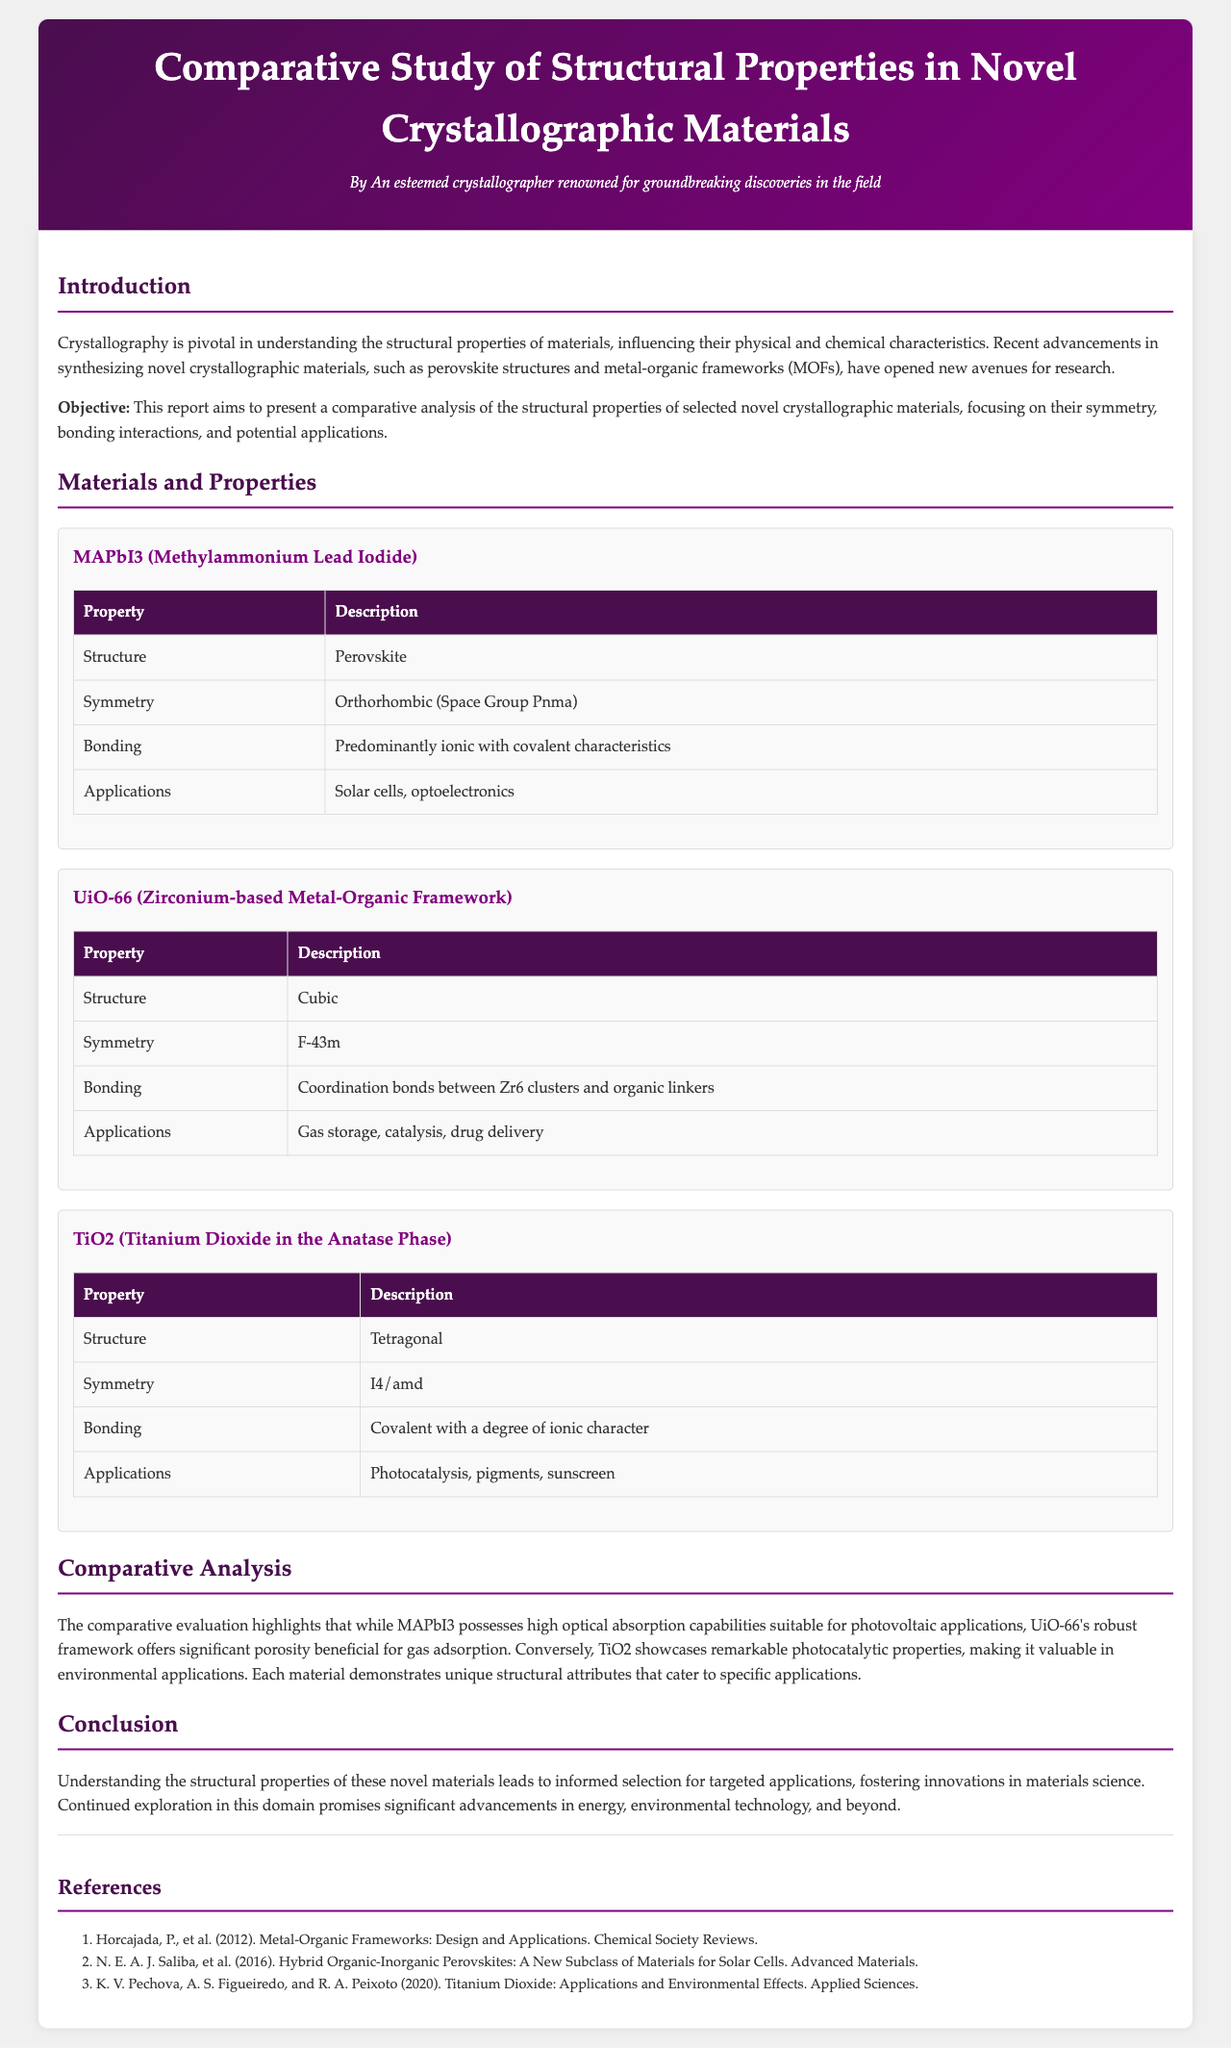what is the main objective of the report? The report aims to present a comparative analysis of the structural properties of selected novel crystallographic materials, focusing on their symmetry, bonding interactions, and potential applications.
Answer: comparative analysis of the structural properties which material has an orthorhombic symmetry? MAPbI3 is specified as having orthorhombic symmetry with Space Group Pnma.
Answer: MAPbI3 what type of bonding is predominantly found in UiO-66? The report indicates that UiO-66 has coordination bonds between Zr6 clusters and organic linkers.
Answer: Coordination bonds what is the application of MAPbI3 mentioned in the report? MAPbI3 is noted for applications in solar cells and optoelectronics.
Answer: Solar cells, optoelectronics which material is described as having remarkable photocatalytic properties? The report states that TiO2 showcases remarkable photocatalytic properties.
Answer: TiO2 what is the structure type of UiO-66? The structure type of UiO-66 is cubic.
Answer: Cubic how many references are listed in the report? The document contains three references listed under the References section.
Answer: Three what unique property does TiO2 possess compared to MAPbI3? TiO2 is noted for its remarkable photocatalytic properties, whereas MAPbI3 has high optical absorption capabilities suitable for photovoltaic applications.
Answer: Photocatalytic properties 